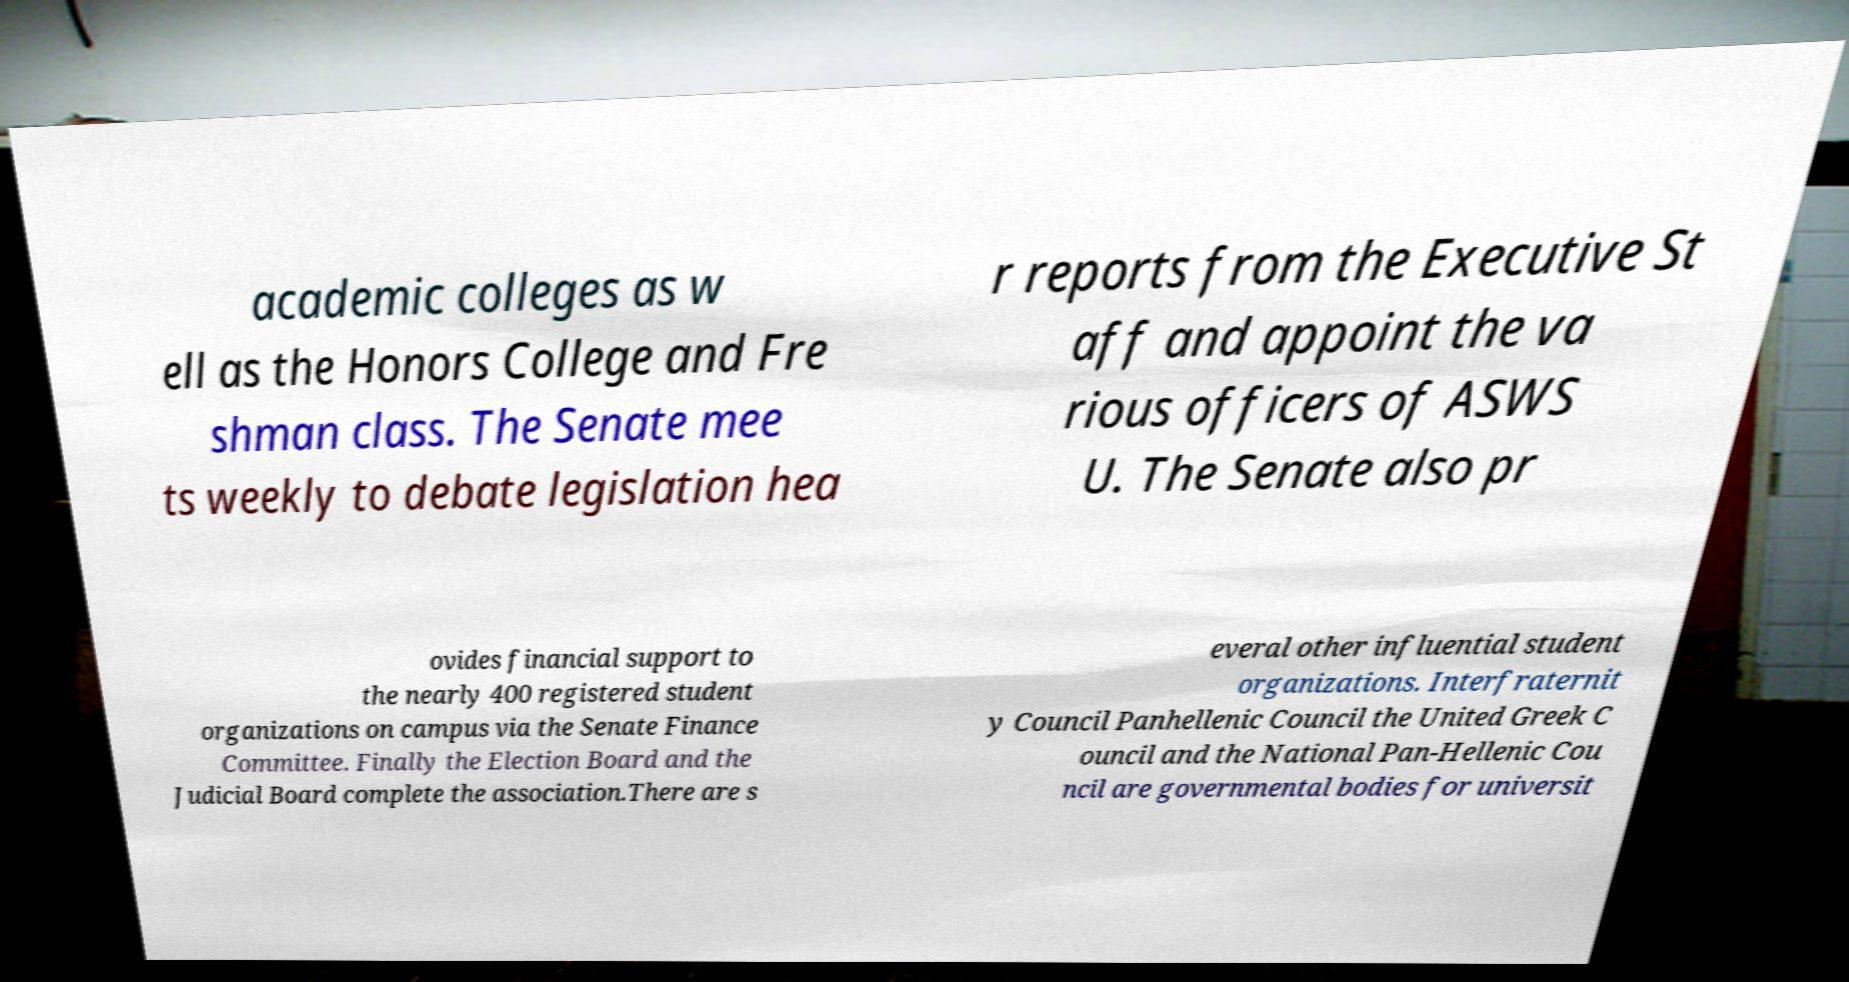There's text embedded in this image that I need extracted. Can you transcribe it verbatim? academic colleges as w ell as the Honors College and Fre shman class. The Senate mee ts weekly to debate legislation hea r reports from the Executive St aff and appoint the va rious officers of ASWS U. The Senate also pr ovides financial support to the nearly 400 registered student organizations on campus via the Senate Finance Committee. Finally the Election Board and the Judicial Board complete the association.There are s everal other influential student organizations. Interfraternit y Council Panhellenic Council the United Greek C ouncil and the National Pan-Hellenic Cou ncil are governmental bodies for universit 